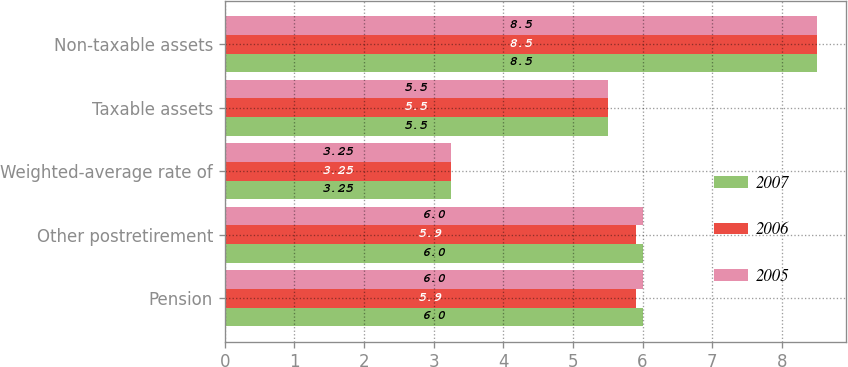Convert chart to OTSL. <chart><loc_0><loc_0><loc_500><loc_500><stacked_bar_chart><ecel><fcel>Pension<fcel>Other postretirement<fcel>Weighted-average rate of<fcel>Taxable assets<fcel>Non-taxable assets<nl><fcel>2007<fcel>6<fcel>6<fcel>3.25<fcel>5.5<fcel>8.5<nl><fcel>2006<fcel>5.9<fcel>5.9<fcel>3.25<fcel>5.5<fcel>8.5<nl><fcel>2005<fcel>6<fcel>6<fcel>3.25<fcel>5.5<fcel>8.5<nl></chart> 